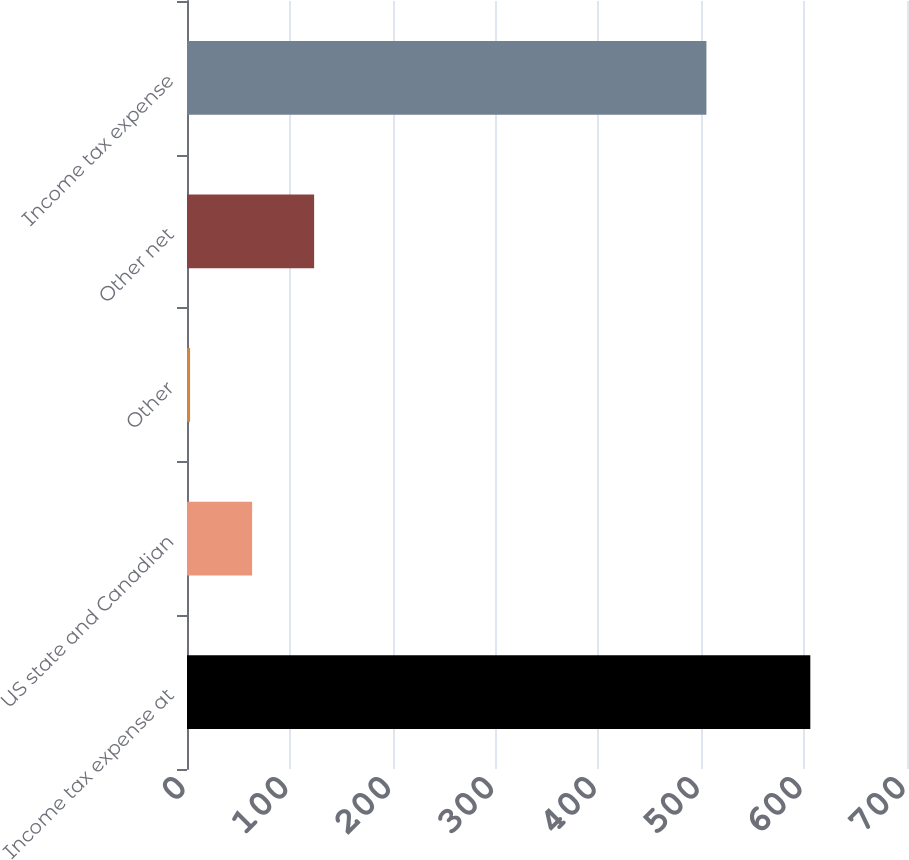Convert chart. <chart><loc_0><loc_0><loc_500><loc_500><bar_chart><fcel>Income tax expense at<fcel>US state and Canadian<fcel>Other<fcel>Other net<fcel>Income tax expense<nl><fcel>606<fcel>63.3<fcel>3<fcel>123.6<fcel>505<nl></chart> 